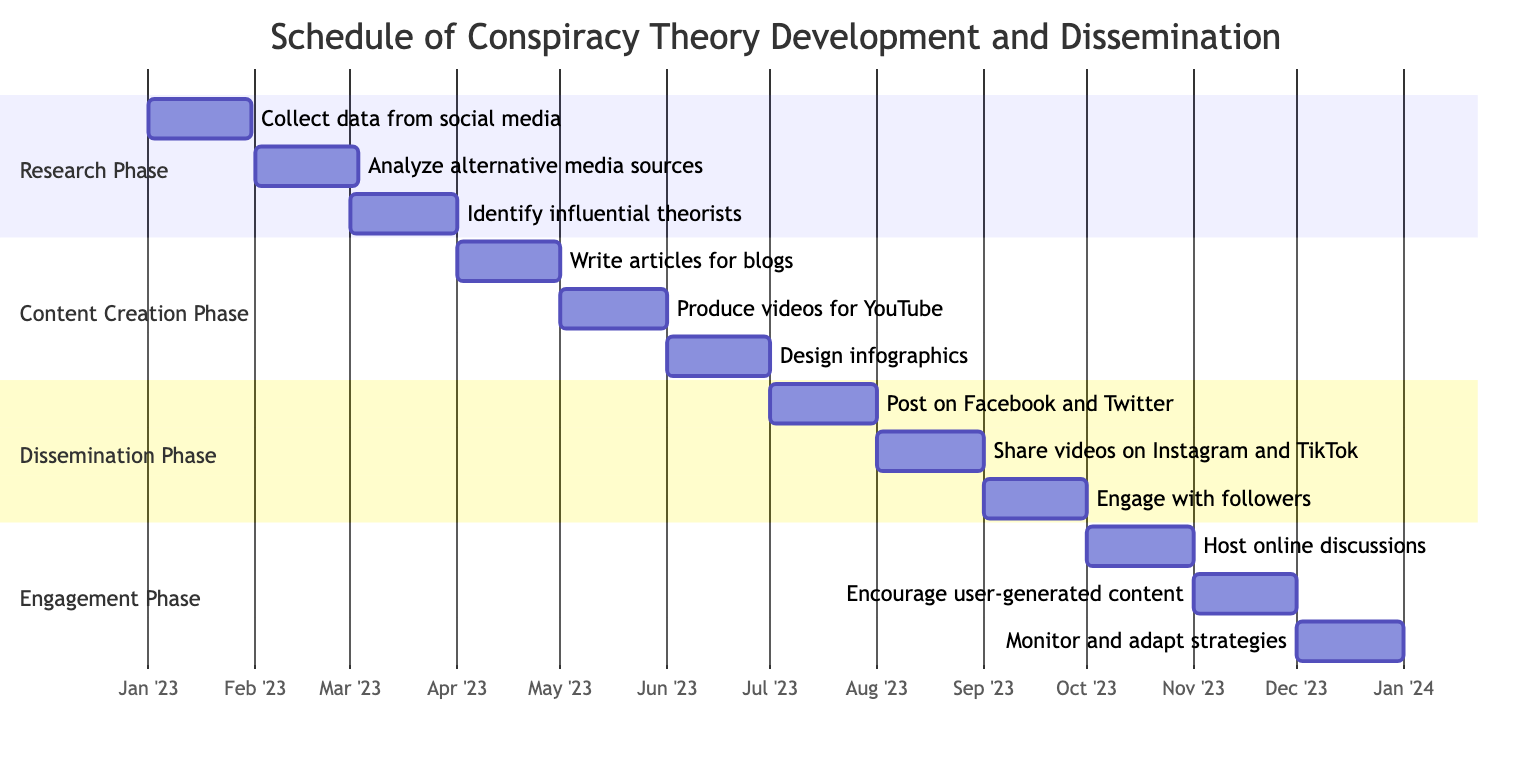What is the duration of the Research Phase? The Research Phase starts on January 1, 2023 and ends on March 31, 2023. The duration can be calculated by counting the days from the start to the end date, which totals 90 days.
Answer: 90 days Which task starts first in the Content Creation Phase? In the Content Creation Phase, the tasks are sequenced by their start dates. The first task is "Write articles for blogs," which begins on April 1, 2023.
Answer: Write articles for blogs How many key tasks are in the Dissemination Phase? The Dissemination Phase includes three key tasks, which are "Post on Facebook and Twitter," "Share videos on Instagram and TikTok," and "Engage with followers." Counting these, we can determine the total.
Answer: 3 What is the last task in the Engagement Phase? The Engagement Phase tasks are listed in order of when they start or finish. The last task listed is "Monitor and adapt strategies," which starts on December 1, 2023 and ends on December 31, 2023.
Answer: Monitor and adapt strategies Which phase has overlapping tasks with the Dissemination Phase? Upon examining the timeline, the Dissemination Phase runs from July 1, 2023 to September 30, 2023. The Engagement Phase starts on October 1, 2023. Since there are no tasks within the Dissemination Phase that overlap into the Engagement Phase, this means they are separate phases with no overlap.
Answer: None What is the total duration of the entire process outlined in the Gantt Chart? To find the total duration, you can check the start date of the first phase (Research Phase starts on January 1, 2023) and the end date of the last phase (Engagement Phase ends on December 31, 2023). Calculating the number of days between these two dates gives a total of 365 days.
Answer: 365 days 